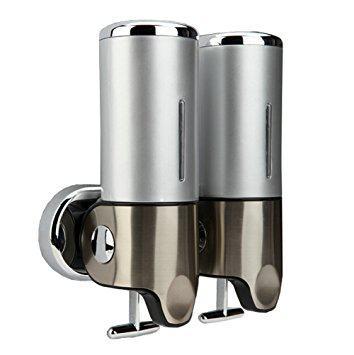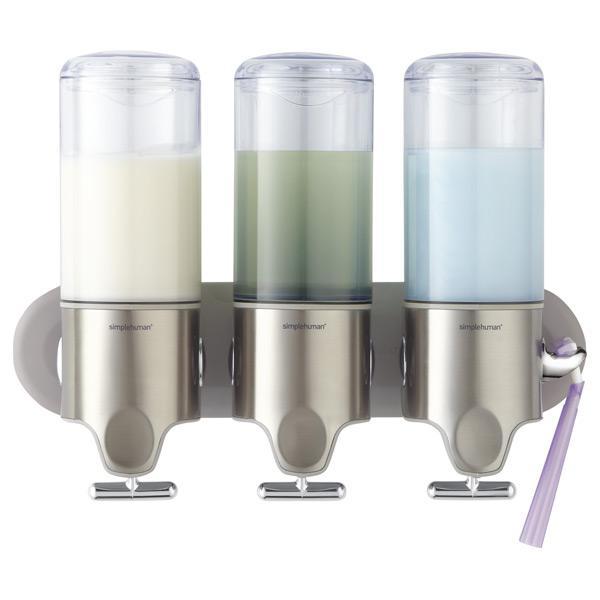The first image is the image on the left, the second image is the image on the right. Given the left and right images, does the statement "At least one image contains three dispensers which are all not transparent." hold true? Answer yes or no. No. The first image is the image on the left, the second image is the image on the right. Considering the images on both sides, is "There are three dispensers in which the top half is fully silver with only one line of an open window to see liquid." valid? Answer yes or no. No. 